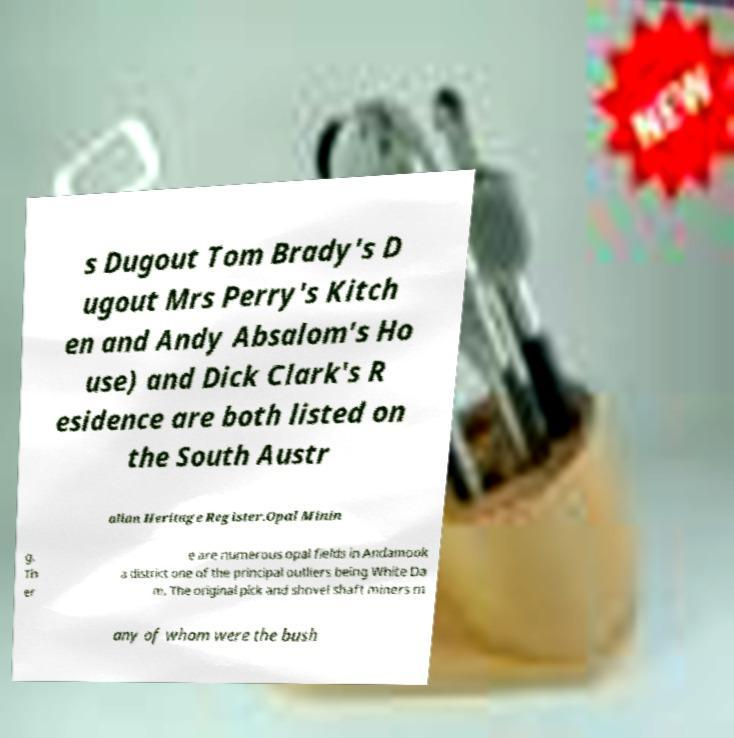There's text embedded in this image that I need extracted. Can you transcribe it verbatim? s Dugout Tom Brady's D ugout Mrs Perry's Kitch en and Andy Absalom's Ho use) and Dick Clark's R esidence are both listed on the South Austr alian Heritage Register.Opal Minin g. Th er e are numerous opal fields in Andamook a district one of the principal outliers being White Da m. The original pick and shovel shaft miners m any of whom were the bush 